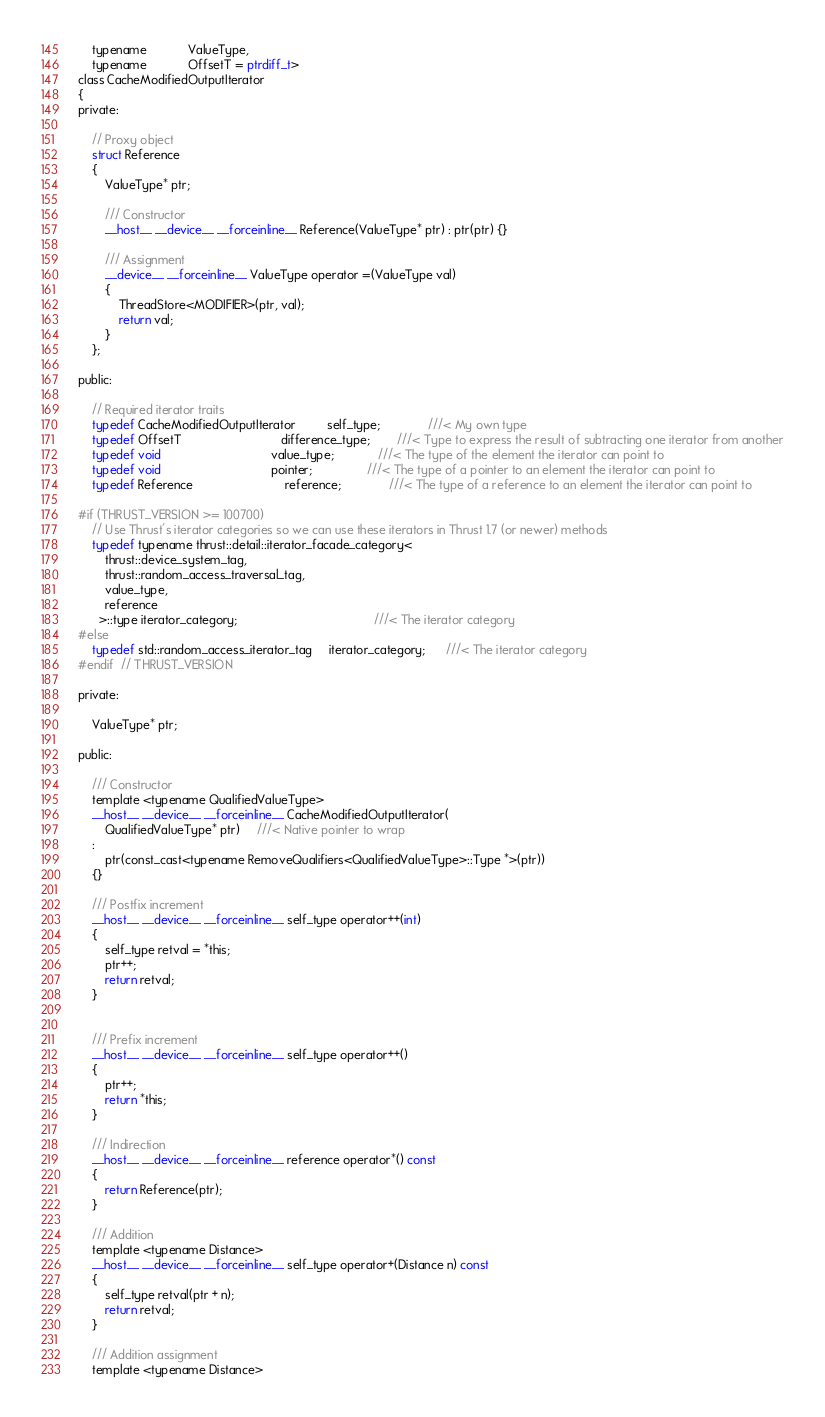<code> <loc_0><loc_0><loc_500><loc_500><_Cuda_>    typename            ValueType,
    typename            OffsetT = ptrdiff_t>
class CacheModifiedOutputIterator
{
private:

    // Proxy object
    struct Reference
    {
        ValueType* ptr;

        /// Constructor
        __host__ __device__ __forceinline__ Reference(ValueType* ptr) : ptr(ptr) {}

        /// Assignment
        __device__ __forceinline__ ValueType operator =(ValueType val)
        {
            ThreadStore<MODIFIER>(ptr, val);
            return val;
        }
    };

public:

    // Required iterator traits
    typedef CacheModifiedOutputIterator         self_type;              ///< My own type
    typedef OffsetT                             difference_type;        ///< Type to express the result of subtracting one iterator from another
    typedef void                                value_type;             ///< The type of the element the iterator can point to
    typedef void                                pointer;                ///< The type of a pointer to an element the iterator can point to
    typedef Reference                           reference;              ///< The type of a reference to an element the iterator can point to

#if (THRUST_VERSION >= 100700)
    // Use Thrust's iterator categories so we can use these iterators in Thrust 1.7 (or newer) methods
    typedef typename thrust::detail::iterator_facade_category<
        thrust::device_system_tag,
        thrust::random_access_traversal_tag,
        value_type,
        reference
      >::type iterator_category;                                        ///< The iterator category
#else
    typedef std::random_access_iterator_tag     iterator_category;      ///< The iterator category
#endif  // THRUST_VERSION

private:

    ValueType* ptr;

public:

    /// Constructor
    template <typename QualifiedValueType>
    __host__ __device__ __forceinline__ CacheModifiedOutputIterator(
        QualifiedValueType* ptr)     ///< Native pointer to wrap
    :
        ptr(const_cast<typename RemoveQualifiers<QualifiedValueType>::Type *>(ptr))
    {}

    /// Postfix increment
    __host__ __device__ __forceinline__ self_type operator++(int)
    {
        self_type retval = *this;
        ptr++;
        return retval;
    }


    /// Prefix increment
    __host__ __device__ __forceinline__ self_type operator++()
    {
        ptr++;
        return *this;
    }

    /// Indirection
    __host__ __device__ __forceinline__ reference operator*() const
    {
        return Reference(ptr);
    }

    /// Addition
    template <typename Distance>
    __host__ __device__ __forceinline__ self_type operator+(Distance n) const
    {
        self_type retval(ptr + n);
        return retval;
    }

    /// Addition assignment
    template <typename Distance></code> 